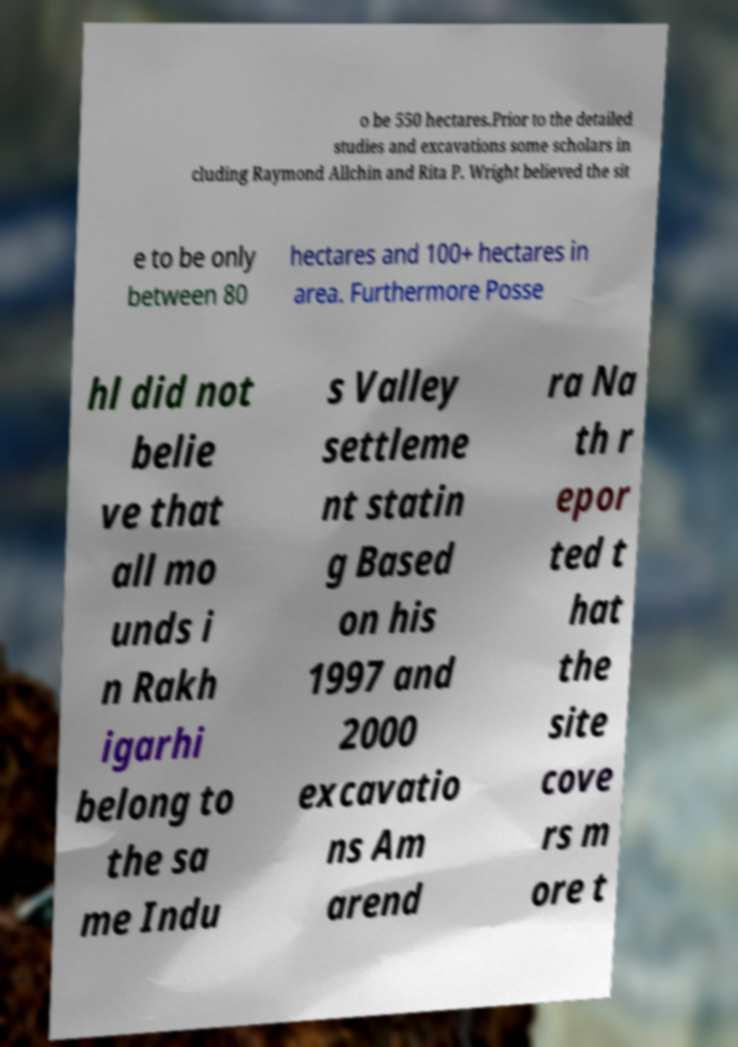Can you accurately transcribe the text from the provided image for me? o be 550 hectares.Prior to the detailed studies and excavations some scholars in cluding Raymond Allchin and Rita P. Wright believed the sit e to be only between 80 hectares and 100+ hectares in area. Furthermore Posse hl did not belie ve that all mo unds i n Rakh igarhi belong to the sa me Indu s Valley settleme nt statin g Based on his 1997 and 2000 excavatio ns Am arend ra Na th r epor ted t hat the site cove rs m ore t 